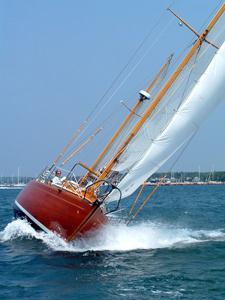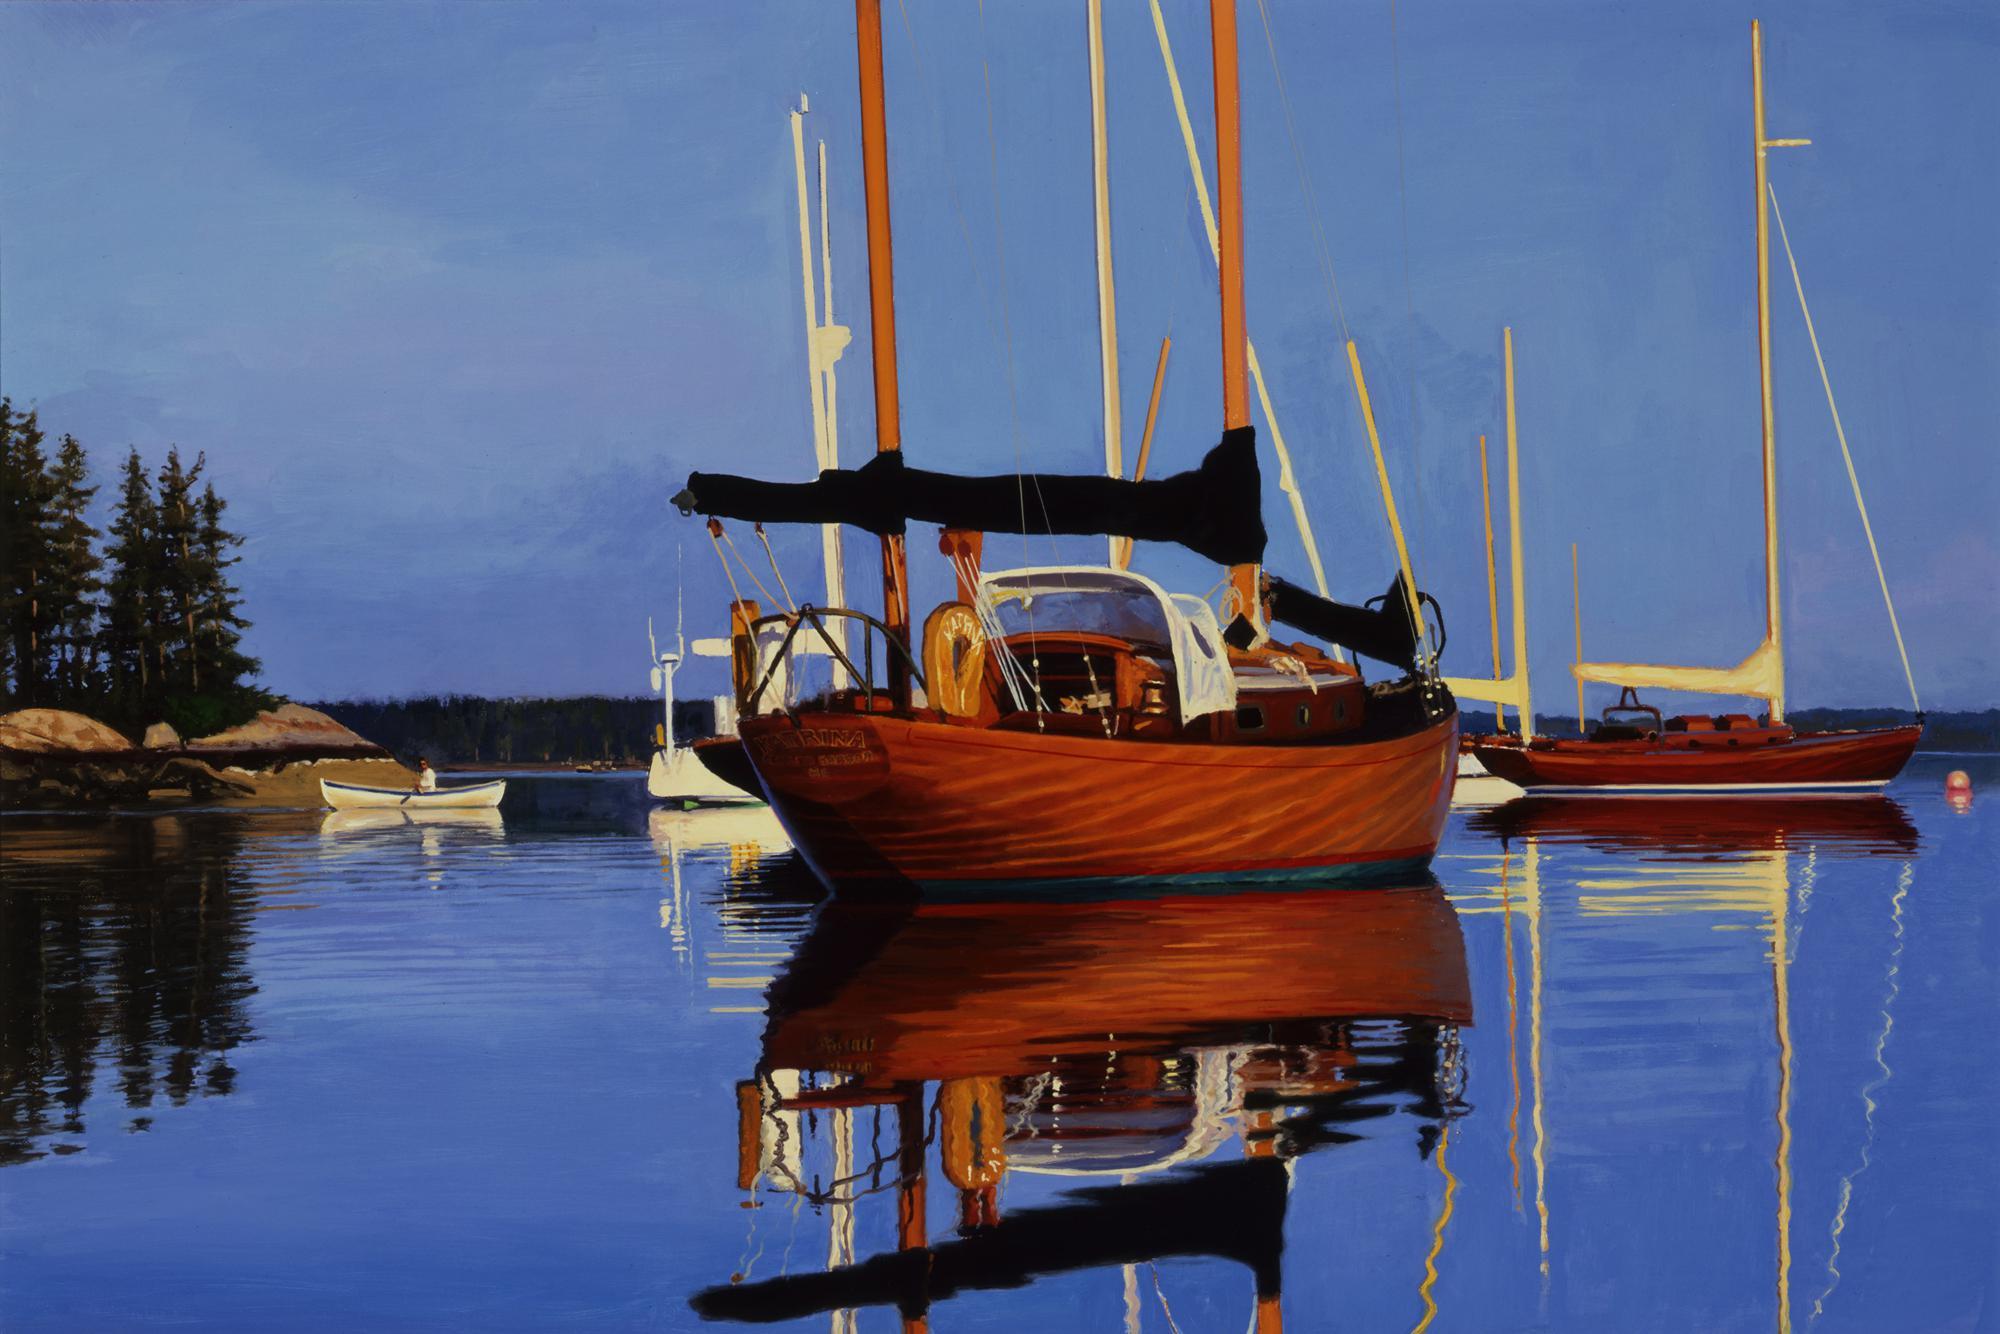The first image is the image on the left, the second image is the image on the right. For the images shown, is this caption "The boat in one image has an unfurled white sail." true? Answer yes or no. Yes. The first image is the image on the left, the second image is the image on the right. Analyze the images presented: Is the assertion "The sails on both of the sailboats are furled." valid? Answer yes or no. No. 